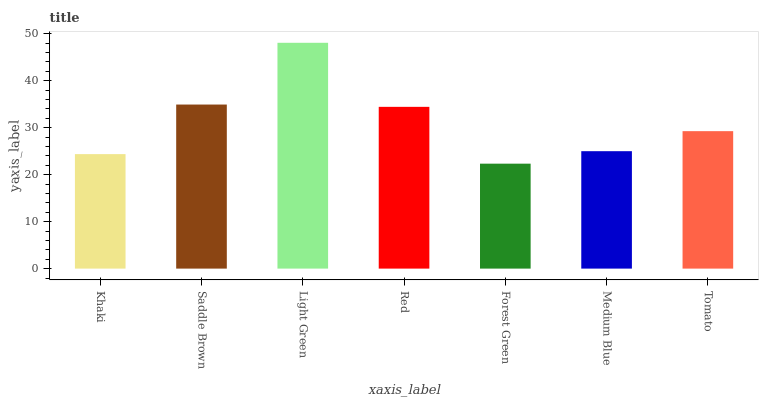Is Forest Green the minimum?
Answer yes or no. Yes. Is Light Green the maximum?
Answer yes or no. Yes. Is Saddle Brown the minimum?
Answer yes or no. No. Is Saddle Brown the maximum?
Answer yes or no. No. Is Saddle Brown greater than Khaki?
Answer yes or no. Yes. Is Khaki less than Saddle Brown?
Answer yes or no. Yes. Is Khaki greater than Saddle Brown?
Answer yes or no. No. Is Saddle Brown less than Khaki?
Answer yes or no. No. Is Tomato the high median?
Answer yes or no. Yes. Is Tomato the low median?
Answer yes or no. Yes. Is Red the high median?
Answer yes or no. No. Is Forest Green the low median?
Answer yes or no. No. 